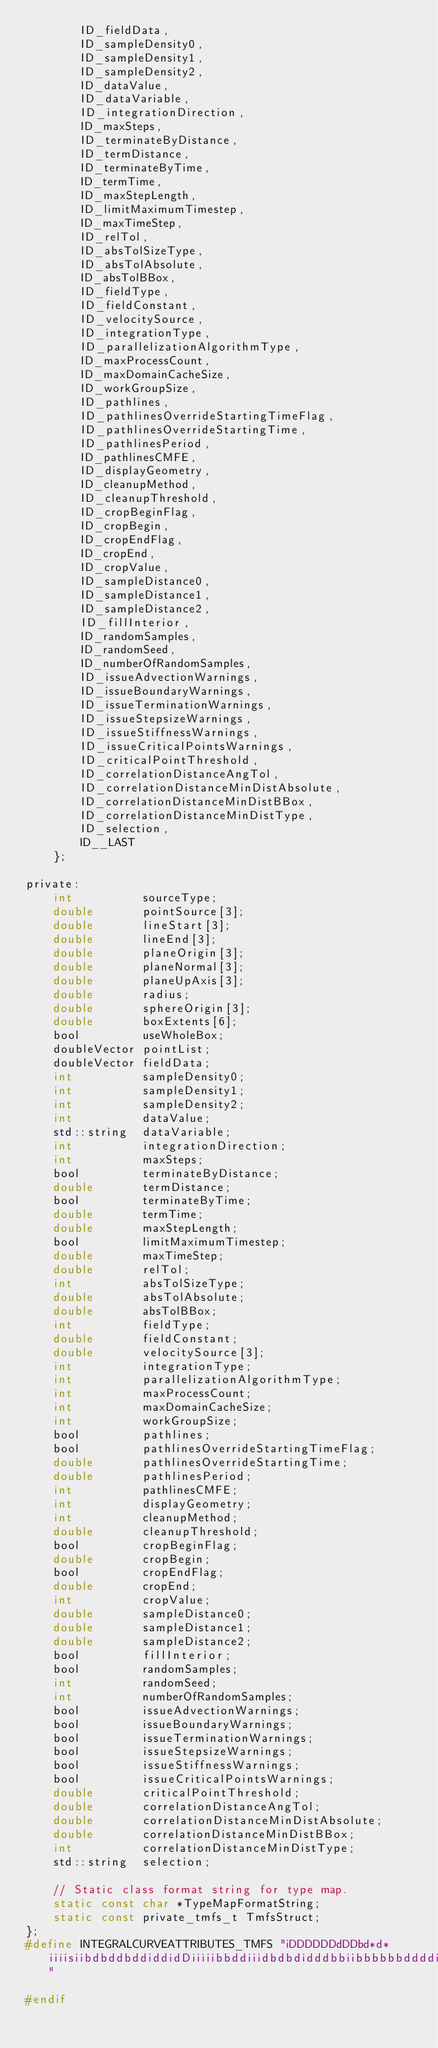<code> <loc_0><loc_0><loc_500><loc_500><_C_>        ID_fieldData,
        ID_sampleDensity0,
        ID_sampleDensity1,
        ID_sampleDensity2,
        ID_dataValue,
        ID_dataVariable,
        ID_integrationDirection,
        ID_maxSteps,
        ID_terminateByDistance,
        ID_termDistance,
        ID_terminateByTime,
        ID_termTime,
        ID_maxStepLength,
        ID_limitMaximumTimestep,
        ID_maxTimeStep,
        ID_relTol,
        ID_absTolSizeType,
        ID_absTolAbsolute,
        ID_absTolBBox,
        ID_fieldType,
        ID_fieldConstant,
        ID_velocitySource,
        ID_integrationType,
        ID_parallelizationAlgorithmType,
        ID_maxProcessCount,
        ID_maxDomainCacheSize,
        ID_workGroupSize,
        ID_pathlines,
        ID_pathlinesOverrideStartingTimeFlag,
        ID_pathlinesOverrideStartingTime,
        ID_pathlinesPeriod,
        ID_pathlinesCMFE,
        ID_displayGeometry,
        ID_cleanupMethod,
        ID_cleanupThreshold,
        ID_cropBeginFlag,
        ID_cropBegin,
        ID_cropEndFlag,
        ID_cropEnd,
        ID_cropValue,
        ID_sampleDistance0,
        ID_sampleDistance1,
        ID_sampleDistance2,
        ID_fillInterior,
        ID_randomSamples,
        ID_randomSeed,
        ID_numberOfRandomSamples,
        ID_issueAdvectionWarnings,
        ID_issueBoundaryWarnings,
        ID_issueTerminationWarnings,
        ID_issueStepsizeWarnings,
        ID_issueStiffnessWarnings,
        ID_issueCriticalPointsWarnings,
        ID_criticalPointThreshold,
        ID_correlationDistanceAngTol,
        ID_correlationDistanceMinDistAbsolute,
        ID_correlationDistanceMinDistBBox,
        ID_correlationDistanceMinDistType,
        ID_selection,
        ID__LAST
    };

private:
    int          sourceType;
    double       pointSource[3];
    double       lineStart[3];
    double       lineEnd[3];
    double       planeOrigin[3];
    double       planeNormal[3];
    double       planeUpAxis[3];
    double       radius;
    double       sphereOrigin[3];
    double       boxExtents[6];
    bool         useWholeBox;
    doubleVector pointList;
    doubleVector fieldData;
    int          sampleDensity0;
    int          sampleDensity1;
    int          sampleDensity2;
    int          dataValue;
    std::string  dataVariable;
    int          integrationDirection;
    int          maxSteps;
    bool         terminateByDistance;
    double       termDistance;
    bool         terminateByTime;
    double       termTime;
    double       maxStepLength;
    bool         limitMaximumTimestep;
    double       maxTimeStep;
    double       relTol;
    int          absTolSizeType;
    double       absTolAbsolute;
    double       absTolBBox;
    int          fieldType;
    double       fieldConstant;
    double       velocitySource[3];
    int          integrationType;
    int          parallelizationAlgorithmType;
    int          maxProcessCount;
    int          maxDomainCacheSize;
    int          workGroupSize;
    bool         pathlines;
    bool         pathlinesOverrideStartingTimeFlag;
    double       pathlinesOverrideStartingTime;
    double       pathlinesPeriod;
    int          pathlinesCMFE;
    int          displayGeometry;
    int          cleanupMethod;
    double       cleanupThreshold;
    bool         cropBeginFlag;
    double       cropBegin;
    bool         cropEndFlag;
    double       cropEnd;
    int          cropValue;
    double       sampleDistance0;
    double       sampleDistance1;
    double       sampleDistance2;
    bool         fillInterior;
    bool         randomSamples;
    int          randomSeed;
    int          numberOfRandomSamples;
    bool         issueAdvectionWarnings;
    bool         issueBoundaryWarnings;
    bool         issueTerminationWarnings;
    bool         issueStepsizeWarnings;
    bool         issueStiffnessWarnings;
    bool         issueCriticalPointsWarnings;
    double       criticalPointThreshold;
    double       correlationDistanceAngTol;
    double       correlationDistanceMinDistAbsolute;
    double       correlationDistanceMinDistBBox;
    int          correlationDistanceMinDistType;
    std::string  selection;

    // Static class format string for type map.
    static const char *TypeMapFormatString;
    static const private_tmfs_t TmfsStruct;
};
#define INTEGRALCURVEATTRIBUTES_TMFS "iDDDDDDdDDbd*d*iiiisiibdbddbddiddidDiiiiibbddiiidbdbdidddbbiibbbbbbddddis"

#endif
</code> 